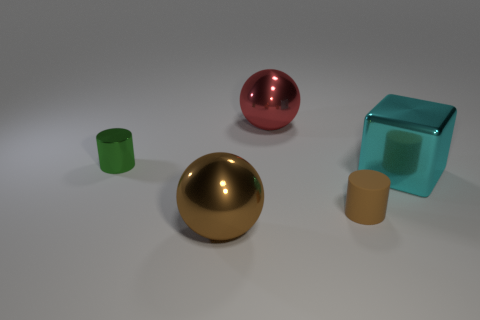Add 3 brown metal balls. How many objects exist? 8 Subtract all cylinders. How many objects are left? 3 Subtract all large things. Subtract all tiny shiny cubes. How many objects are left? 2 Add 2 small green cylinders. How many small green cylinders are left? 3 Add 3 purple rubber cylinders. How many purple rubber cylinders exist? 3 Subtract 0 purple balls. How many objects are left? 5 